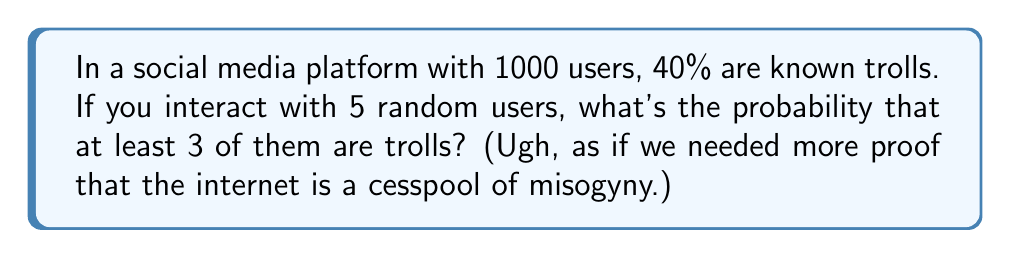Provide a solution to this math problem. Let's approach this step-by-step using combinatorics:

1) First, we need to calculate the probability of a single user being a troll:
   $p(\text{troll}) = 0.40$

2) The probability of a user not being a troll is:
   $p(\text{not troll}) = 1 - 0.40 = 0.60$

3) We want the probability of at least 3 out of 5 users being trolls. This can happen in three ways:
   - Exactly 3 out of 5 are trolls
   - Exactly 4 out of 5 are trolls
   - All 5 are trolls

4) Let's calculate each of these probabilities using the binomial probability formula:
   $$P(X = k) = \binom{n}{k} p^k (1-p)^{n-k}$$

   Where $n$ is the number of trials (5 in this case), $k$ is the number of successes, $p$ is the probability of success on a single trial.

5) For 3 out of 5:
   $$P(X = 3) = \binom{5}{3} (0.40)^3 (0.60)^2 = 10 \cdot 0.064 \cdot 0.36 = 0.2304$$

6) For 4 out of 5:
   $$P(X = 4) = \binom{5}{4} (0.40)^4 (0.60)^1 = 5 \cdot 0.0256 \cdot 0.60 = 0.0768$$

7) For 5 out of 5:
   $$P(X = 5) = \binom{5}{5} (0.40)^5 (0.60)^0 = 1 \cdot 0.01024 \cdot 1 = 0.01024$$

8) The total probability is the sum of these three probabilities:
   $$P(\text{at least 3 trolls}) = 0.2304 + 0.0768 + 0.01024 = 0.31744$$
Answer: The probability of encountering at least 3 trolls out of 5 random users is approximately 0.3174 or 31.74%. 